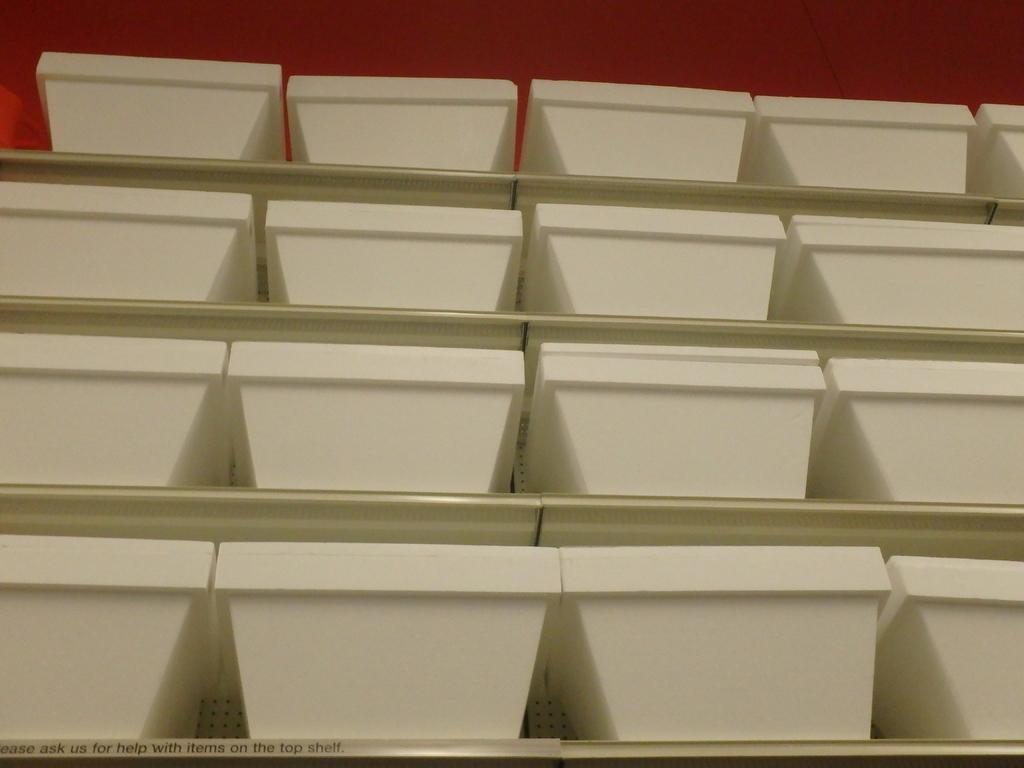In one or two sentences, can you explain what this image depicts? In the image there are many bowls kept in the shelves, the bowls are of white color. 